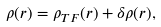Convert formula to latex. <formula><loc_0><loc_0><loc_500><loc_500>\rho ( r ) = \rho _ { T F } ( r ) + \delta \rho ( r ) ,</formula> 